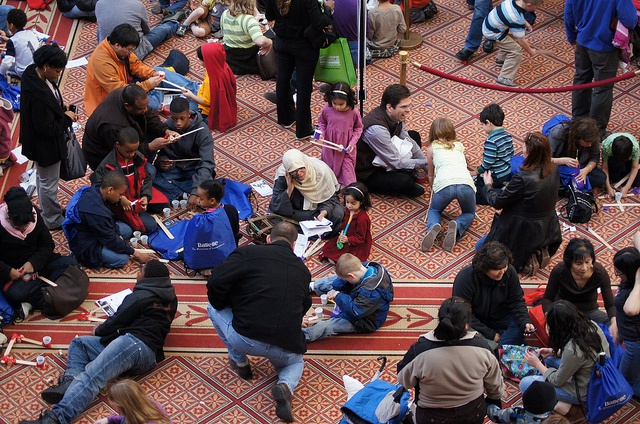Describe the objects in this image and their specific colors. I can see people in tan, black, brown, gray, and darkgray tones, people in tan, black, gray, and navy tones, people in tan, black, gray, and darkgray tones, people in tan, black, gray, and navy tones, and people in tan, black, maroon, navy, and gray tones in this image. 